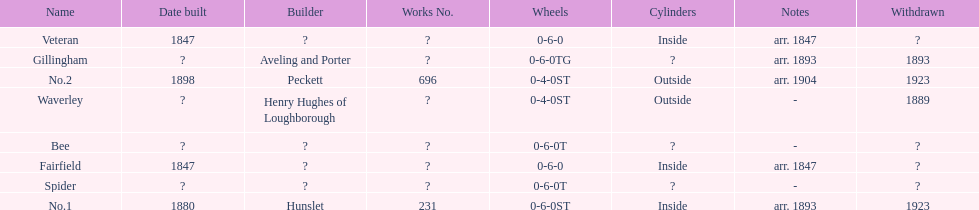Did fairfield or waverley have inside cylinders? Fairfield. 